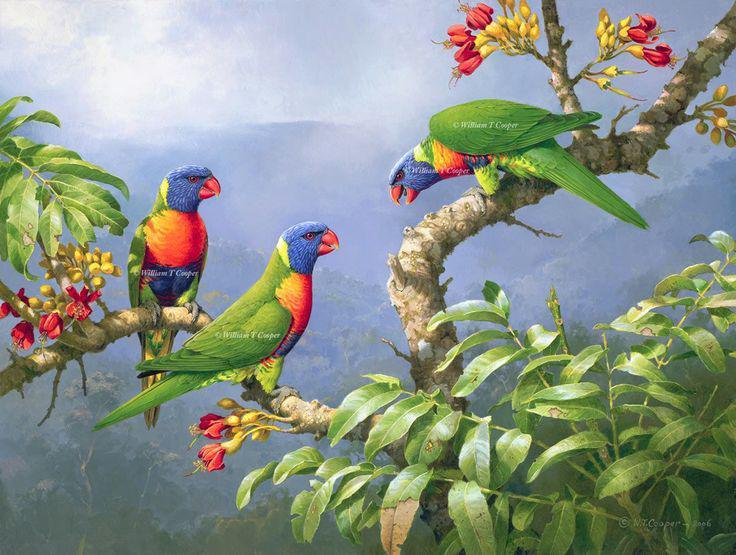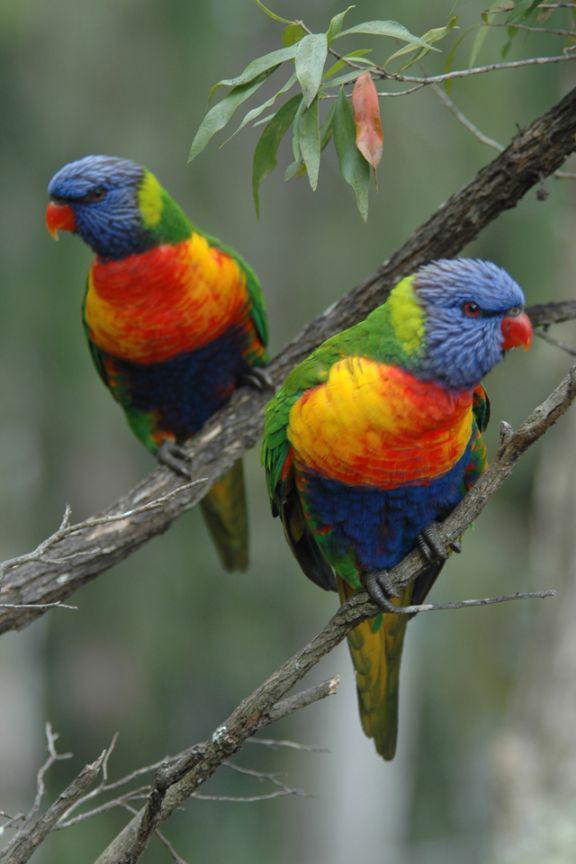The first image is the image on the left, the second image is the image on the right. For the images shown, is this caption "There are no more than four birds" true? Answer yes or no. No. The first image is the image on the left, the second image is the image on the right. Analyze the images presented: Is the assertion "Right image contains exactly one parrot." valid? Answer yes or no. No. 